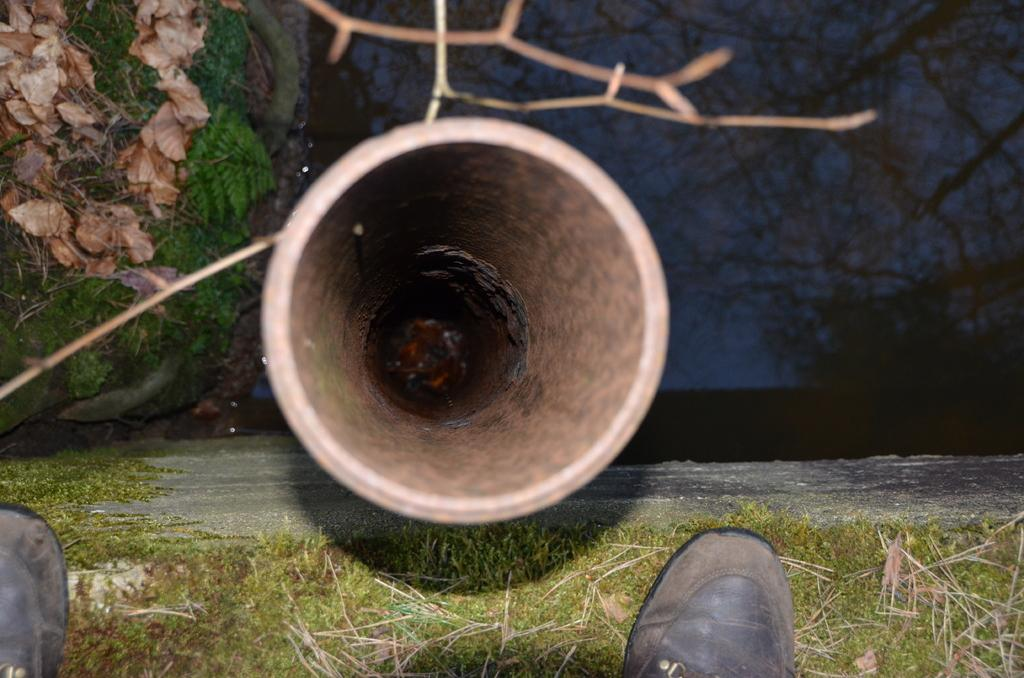What is the main structure visible in the image? There is a pipeline in the image. What type of vegetation can be seen in the image? There is grass and trees in the image. What else is present in the image besides the pipeline and vegetation? There are twigs, the sky, and shoes visible in the image. What type of horse can be seen grazing on the potato in the image? There is no horse or potato present in the image. What type of stew is being prepared in the image? There is no stew being prepared in the image. 